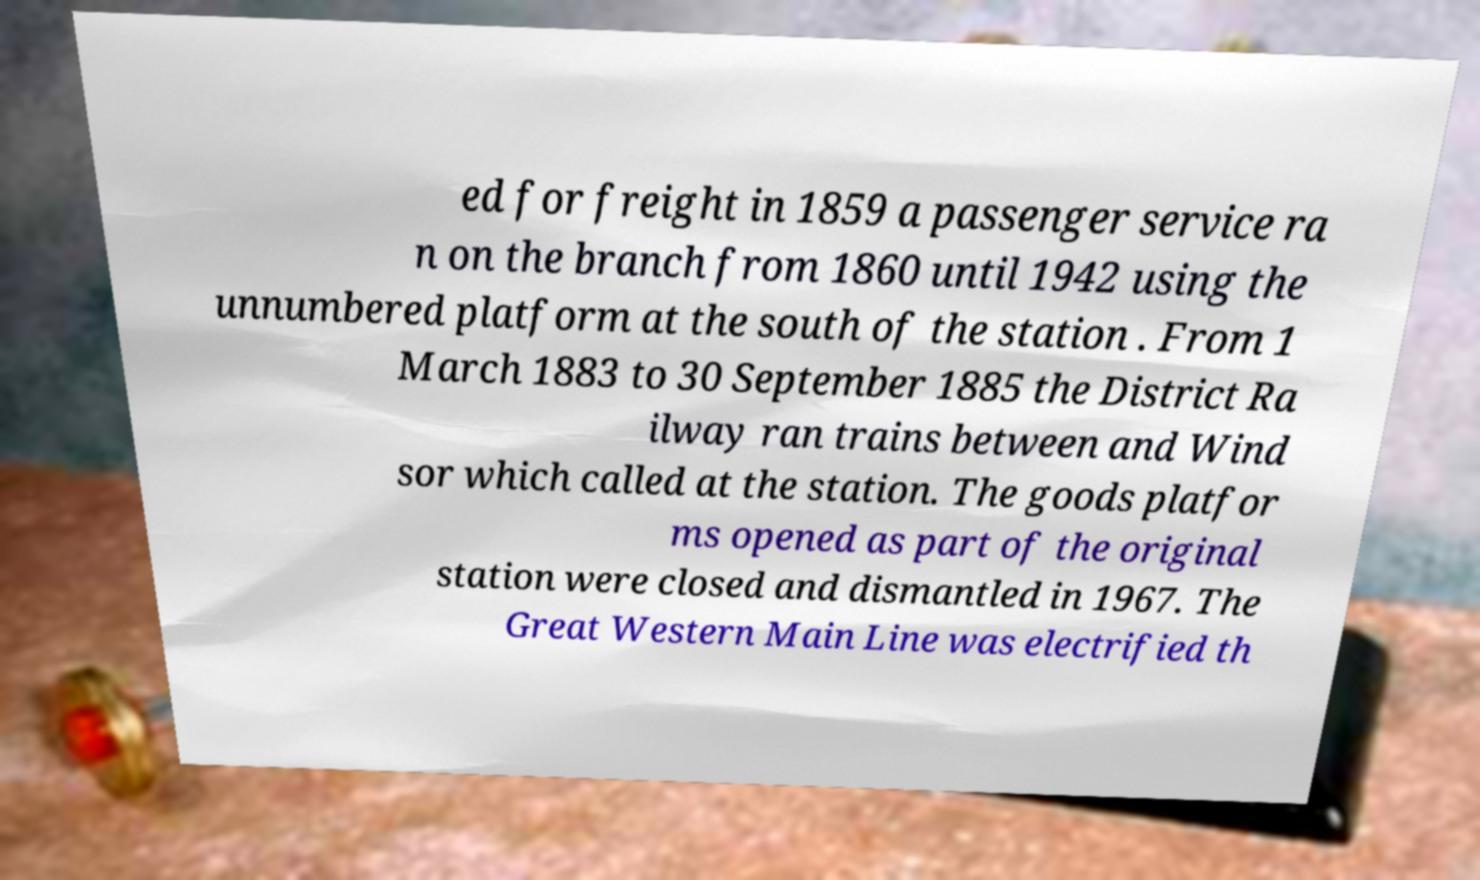There's text embedded in this image that I need extracted. Can you transcribe it verbatim? ed for freight in 1859 a passenger service ra n on the branch from 1860 until 1942 using the unnumbered platform at the south of the station . From 1 March 1883 to 30 September 1885 the District Ra ilway ran trains between and Wind sor which called at the station. The goods platfor ms opened as part of the original station were closed and dismantled in 1967. The Great Western Main Line was electrified th 